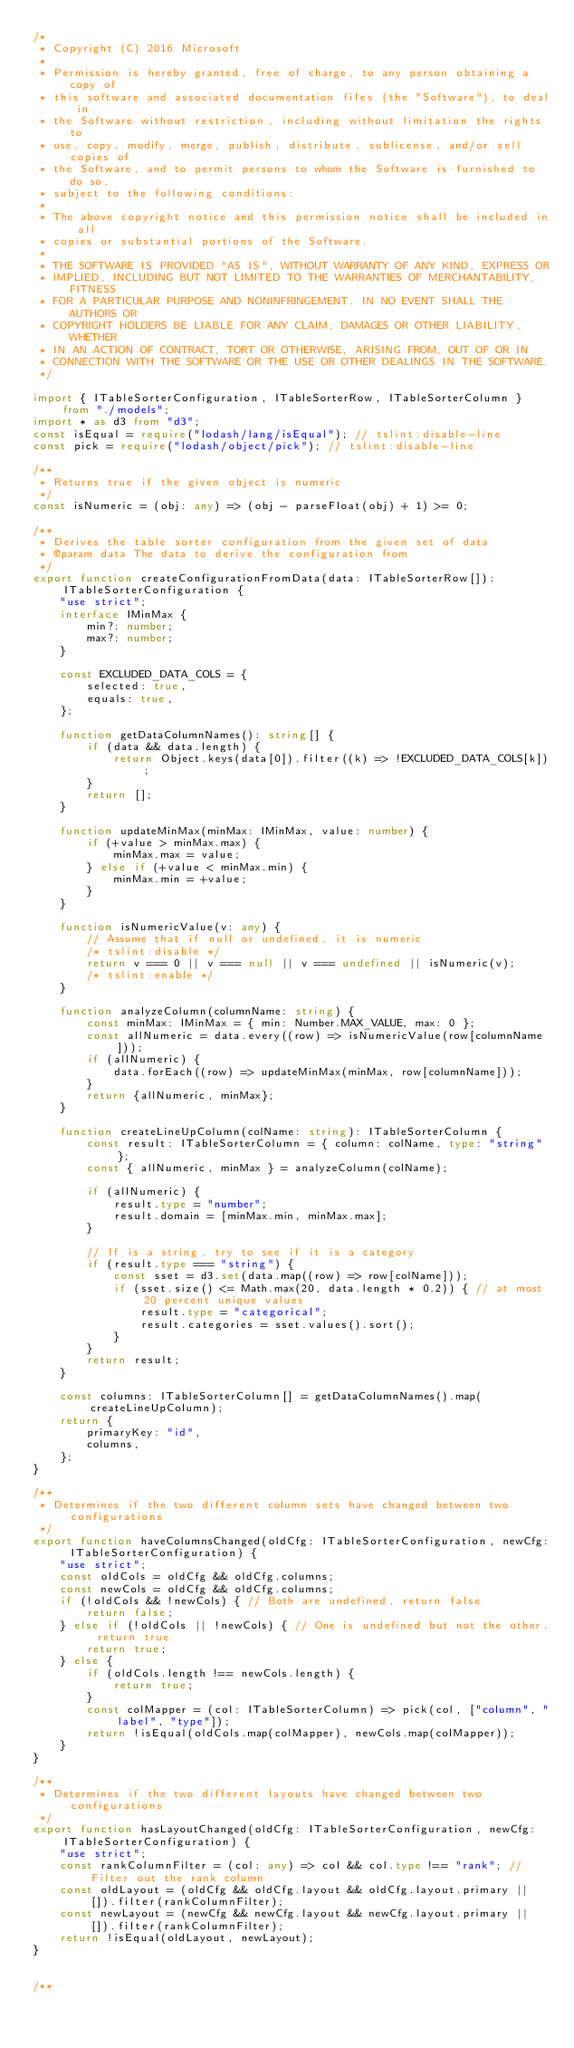Convert code to text. <code><loc_0><loc_0><loc_500><loc_500><_TypeScript_>/*
 * Copyright (C) 2016 Microsoft
 *
 * Permission is hereby granted, free of charge, to any person obtaining a copy of
 * this software and associated documentation files (the "Software"), to deal in
 * the Software without restriction, including without limitation the rights to
 * use, copy, modify, merge, publish, distribute, sublicense, and/or sell copies of
 * the Software, and to permit persons to whom the Software is furnished to do so,
 * subject to the following conditions:
 *
 * The above copyright notice and this permission notice shall be included in all
 * copies or substantial portions of the Software.
 *
 * THE SOFTWARE IS PROVIDED "AS IS", WITHOUT WARRANTY OF ANY KIND, EXPRESS OR
 * IMPLIED, INCLUDING BUT NOT LIMITED TO THE WARRANTIES OF MERCHANTABILITY, FITNESS
 * FOR A PARTICULAR PURPOSE AND NONINFRINGEMENT. IN NO EVENT SHALL THE AUTHORS OR
 * COPYRIGHT HOLDERS BE LIABLE FOR ANY CLAIM, DAMAGES OR OTHER LIABILITY, WHETHER
 * IN AN ACTION OF CONTRACT, TORT OR OTHERWISE, ARISING FROM, OUT OF OR IN
 * CONNECTION WITH THE SOFTWARE OR THE USE OR OTHER DEALINGS IN THE SOFTWARE.
 */

import { ITableSorterConfiguration, ITableSorterRow, ITableSorterColumn } from "./models";
import * as d3 from "d3";
const isEqual = require("lodash/lang/isEqual"); // tslint:disable-line
const pick = require("lodash/object/pick"); // tslint:disable-line

/**
 * Returns true if the given object is numeric
 */
const isNumeric = (obj: any) => (obj - parseFloat(obj) + 1) >= 0;

/**
 * Derives the table sorter configuration from the given set of data
 * @param data The data to derive the configuration from
 */
export function createConfigurationFromData(data: ITableSorterRow[]): ITableSorterConfiguration {
    "use strict";
    interface IMinMax {
        min?: number;
        max?: number;
    }

    const EXCLUDED_DATA_COLS = {
        selected: true,
        equals: true,
    };

    function getDataColumnNames(): string[] {
        if (data && data.length) {
            return Object.keys(data[0]).filter((k) => !EXCLUDED_DATA_COLS[k]);
        }
        return [];
    }

    function updateMinMax(minMax: IMinMax, value: number) {
        if (+value > minMax.max) {
            minMax.max = value;
        } else if (+value < minMax.min) {
            minMax.min = +value;
        }
    }

    function isNumericValue(v: any) {
        // Assume that if null or undefined, it is numeric
        /* tslint:disable */
        return v === 0 || v === null || v === undefined || isNumeric(v);
        /* tslint:enable */
    }

    function analyzeColumn(columnName: string) {
        const minMax: IMinMax = { min: Number.MAX_VALUE, max: 0 };
        const allNumeric = data.every((row) => isNumericValue(row[columnName]));
        if (allNumeric) {
            data.forEach((row) => updateMinMax(minMax, row[columnName]));
        }
        return {allNumeric, minMax};
    }

    function createLineUpColumn(colName: string): ITableSorterColumn {
        const result: ITableSorterColumn = { column: colName, type: "string" };
        const { allNumeric, minMax } = analyzeColumn(colName);

        if (allNumeric) {
            result.type = "number";
            result.domain = [minMax.min, minMax.max];
        }

        // If is a string, try to see if it is a category
        if (result.type === "string") {
            const sset = d3.set(data.map((row) => row[colName]));
            if (sset.size() <= Math.max(20, data.length * 0.2)) { // at most 20 percent unique values
                result.type = "categorical";
                result.categories = sset.values().sort();
            }
        }
        return result;
    }

    const columns: ITableSorterColumn[] = getDataColumnNames().map(createLineUpColumn);
    return {
        primaryKey: "id",
        columns,
    };
}

/**
 * Determines if the two different column sets have changed between two configurations
 */
export function haveColumnsChanged(oldCfg: ITableSorterConfiguration, newCfg: ITableSorterConfiguration) {
    "use strict";
    const oldCols = oldCfg && oldCfg.columns;
    const newCols = oldCfg && oldCfg.columns;
    if (!oldCols && !newCols) { // Both are undefined, return false
        return false;
    } else if (!oldCols || !newCols) { // One is undefined but not the other, return true
        return true;
    } else {
        if (oldCols.length !== newCols.length) {
            return true;
        }
        const colMapper = (col: ITableSorterColumn) => pick(col, ["column", "label", "type"]);
        return !isEqual(oldCols.map(colMapper), newCols.map(colMapper));
    }
}

/**
 * Determines if the two different layouts have changed between two configurations
 */
export function hasLayoutChanged(oldCfg: ITableSorterConfiguration, newCfg: ITableSorterConfiguration) {
    "use strict";
    const rankColumnFilter = (col: any) => col && col.type !== "rank"; // Filter out the rank column
    const oldLayout = (oldCfg && oldCfg.layout && oldCfg.layout.primary || []).filter(rankColumnFilter);
    const newLayout = (newCfg && newCfg.layout && newCfg.layout.primary || []).filter(rankColumnFilter);
    return !isEqual(oldLayout, newLayout);
}


/**</code> 